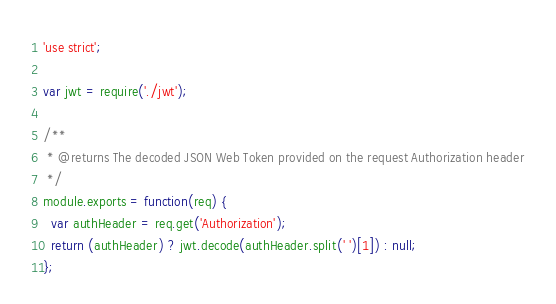<code> <loc_0><loc_0><loc_500><loc_500><_JavaScript_>'use strict';

var jwt = require('./jwt');

/**
 * @returns The decoded JSON Web Token provided on the request Authorization header
 */
module.exports = function(req) {
  var authHeader = req.get('Authorization');
  return (authHeader) ? jwt.decode(authHeader.split(' ')[1]) : null;
};
</code> 